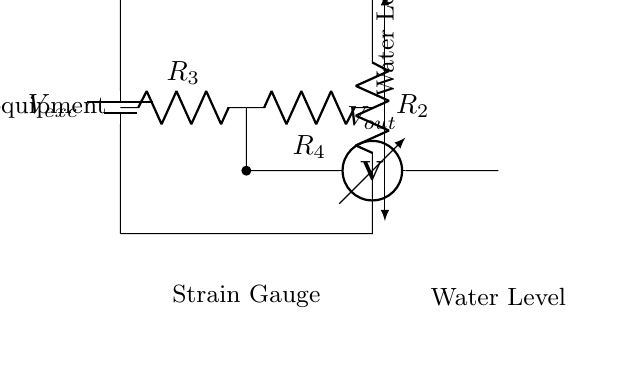What type of circuit is illustrated? The circuit shown is a bridge circuit, characterized by its arrangement of resistors and voltage measurements, specifically designed to measure variations in resistance, such as those from a strain gauge.
Answer: Bridge circuit What does the strain gauge measure? The strain gauge in this circuit measures the deformation or strain, which in this case corresponds to changes in water level in the exercise equipment.
Answer: Water level How many resistors are in the circuit? The circuit contains four resistors, labeled R1, R2, R3, and R4, which play a critical role in balancing the bridge and measuring output voltage.
Answer: Four What is the purpose of the output voltage measurement? The output voltage measurement, indicated as Vout, is used to detect the imbalance in the bridge created by changes in the strain gauge resistance, resulting from the water level changes in the equipment.
Answer: Measure imbalance What happens to the output voltage if the water level increases? If the water level increases, it exerts a greater strain on the strain gauge, which alters its resistance, thereby causing an increase or decrease in the output voltage, depending on the configuration of the resistors in the bridge.
Answer: Changes Which component provides the excitation voltage? The battery, labeled Vexc, supplies the excitation voltage necessary for the operation of the strain gauge bridge circuit, allowing it to function and measure the input.
Answer: Battery 